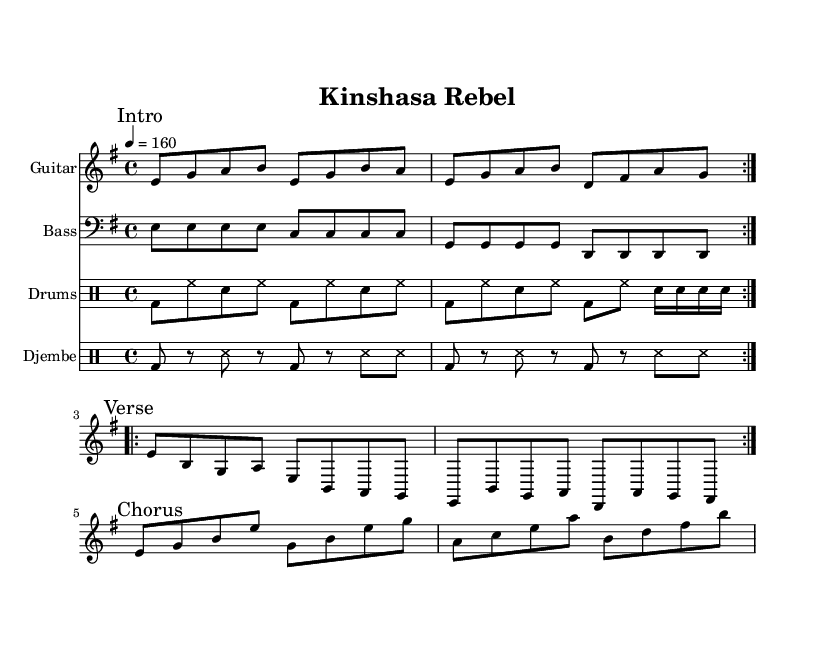What is the key signature of this music? The key signature is E minor, which is indicated by the one sharp (F#) shown at the beginning of the staff.
Answer: E minor What is the time signature of this piece? The time signature is 4/4, meaning there are four beats in each measure, and the quarter note gets one beat. This is specified right after the key signature.
Answer: 4/4 What is the tempo marking of the song? The tempo marking shows a brisk pace at 160 beats per minute, indicated at the beginning of the score.
Answer: 160 How many times does the guitar riff repeat? The guitar riff is marked to repeat twice as indicated by the 'repeat volta 2' marking before the section.
Answer: 2 What types of percussion instruments are included in this piece? The percussion section includes drums and djembe, both shown as separate staff sections labeled accordingly, each with their own rhythmic parts.
Answer: Drums, djembe What chord progression is primarily used in the chorus? The chorus features a harmonic structure that emphasizes E major and C major based on the notes played, but the specific chord progression is not explicitly written out in standard notation.
Answer: E major, C major How does the djembe part contribute to the overall rhythm? The djembe part adds to the polyrhythmic texture typical of African rhythms, interplaying with the straight beat of the drums, as indicated by its unique rhythmic pattern marked in the score.
Answer: Polyrhythmic texture 